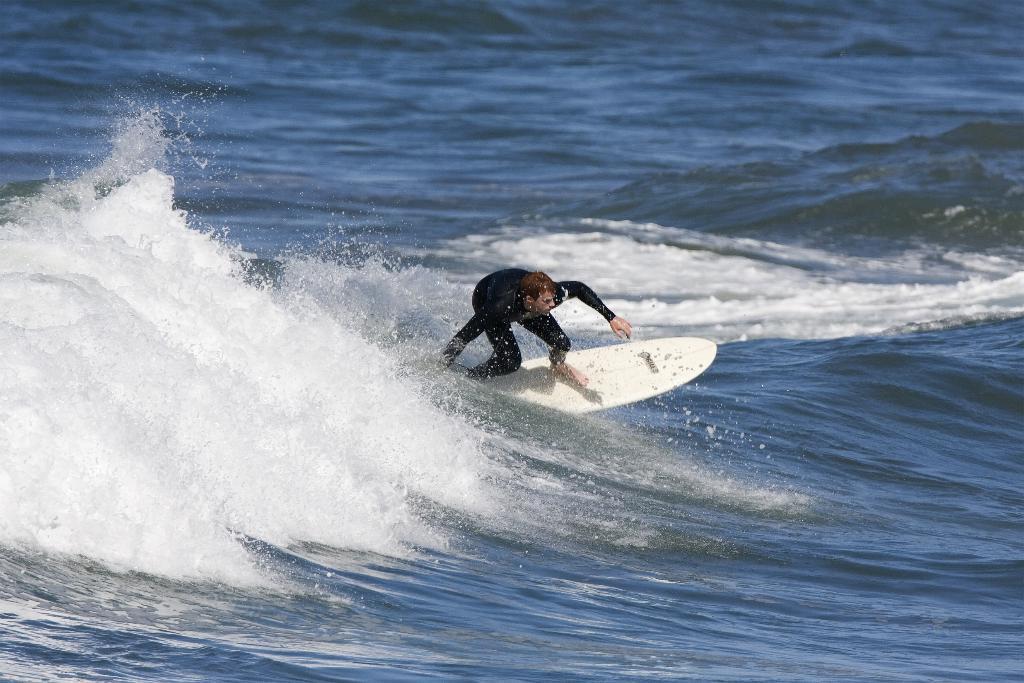Could you give a brief overview of what you see in this image? This image consists of a man surfing in an ocean. At the bottom, there is white color surfboard. He is wearing black dress. 